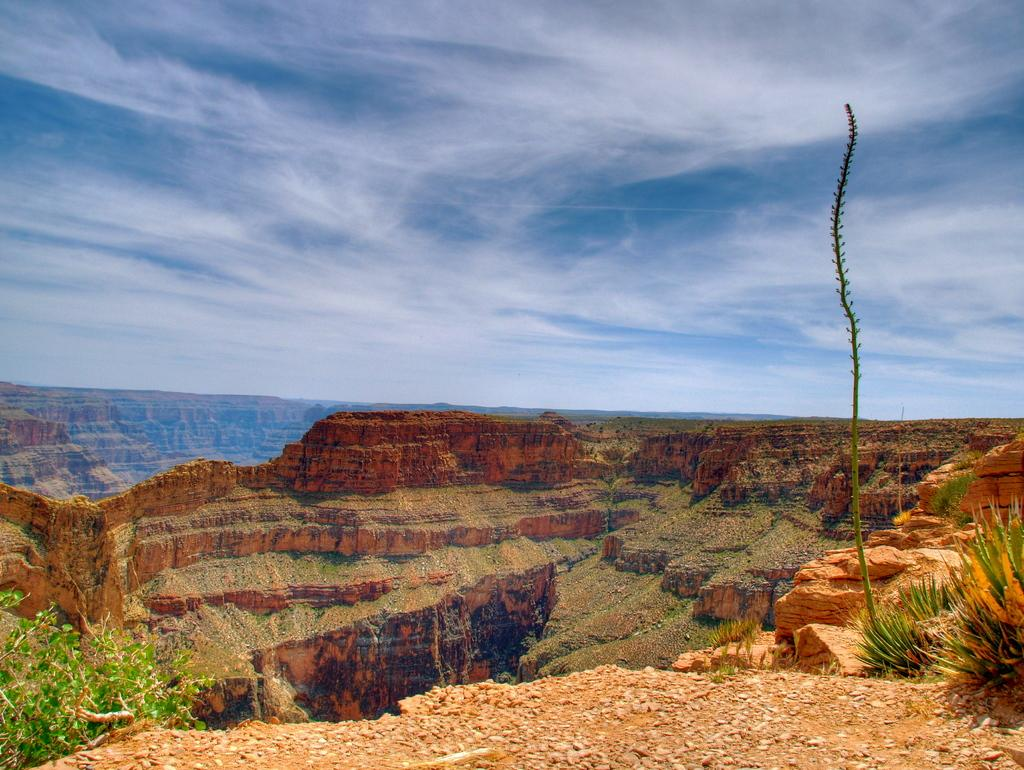What type of geographical feature is depicted in the image? The image appears to depict plateaus. Are there any living organisms visible in the image? Yes, there are plants visible in the image. Can you identify any specific plant in the image? There is a tree in the image. What is visible in the sky in the image? Clouds are present in the sky in the image. What type of cakes are being served on the stage in the image? There is no stage or cakes present in the image; it depicts plateaus with plants and a tree. 